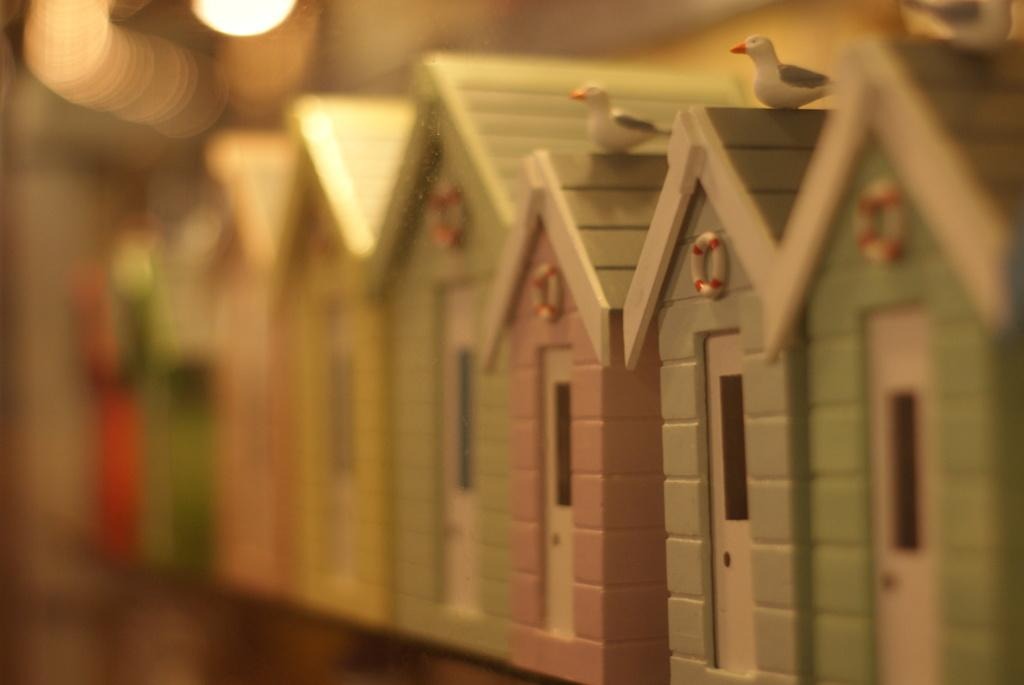What type of toys are present in the image? There are toy wooden shelters in the image. Can you describe the appearance of the toys? The toys are wooden shelters. What type of pest can be seen living inside the wooden shelters in the image? There is no pest visible inside the wooden shelters in the image. What type of bird can be seen perched on top of the wooden shelters in the image? There is no bird visible on top of the wooden shelters in the image. 